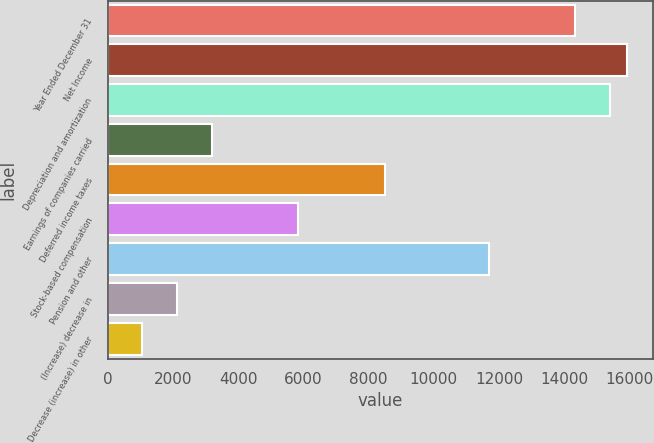<chart> <loc_0><loc_0><loc_500><loc_500><bar_chart><fcel>Year Ended December 31<fcel>Net Income<fcel>Depreciation and amortization<fcel>Earnings of companies carried<fcel>Deferred income taxes<fcel>Stock-based compensation<fcel>Pension and other<fcel>(Increase) decrease in<fcel>Decrease (increase) in other<nl><fcel>14332.9<fcel>15925<fcel>15394.3<fcel>3188.2<fcel>8495.2<fcel>5841.7<fcel>11679.4<fcel>2126.8<fcel>1065.4<nl></chart> 